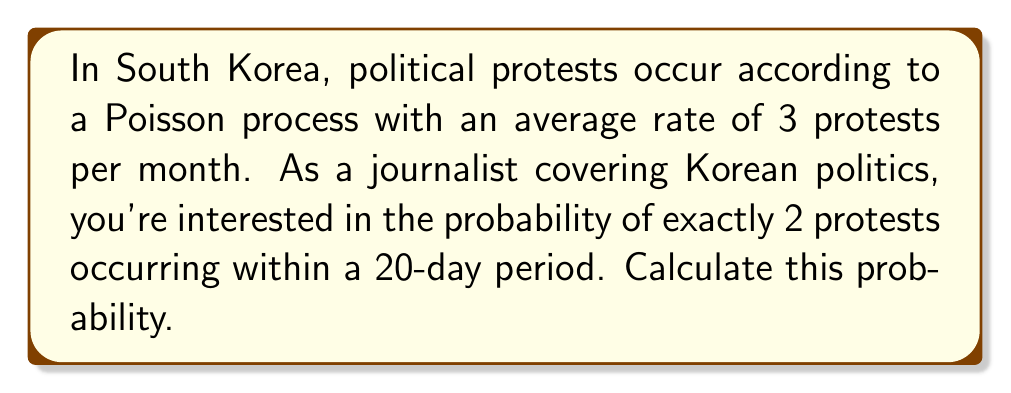Provide a solution to this math problem. To solve this problem, we'll use the Poisson distribution formula:

$$P(X = k) = \frac{e^{-\lambda} \lambda^k}{k!}$$

Where:
- $X$ is the number of events
- $k$ is the specific number of events we're interested in
- $\lambda$ is the average rate of events for the given time period

Steps:
1) First, we need to calculate $\lambda$ for a 20-day period:
   - Rate is 3 protests per month
   - 20 days is approximately $\frac{20}{30} = \frac{2}{3}$ of a month
   - $\lambda = 3 \cdot \frac{2}{3} = 2$

2) Now we can plug into the Poisson formula:
   - $k = 2$ (we want exactly 2 protests)
   - $\lambda = 2$

   $$P(X = 2) = \frac{e^{-2} 2^2}{2!}$$

3) Calculate:
   $$P(X = 2) = \frac{e^{-2} \cdot 4}{2} = 2e^{-2}$$

4) Evaluate:
   $$P(X = 2) \approx 0.2707$$
Answer: $0.2707$ or $27.07\%$ 